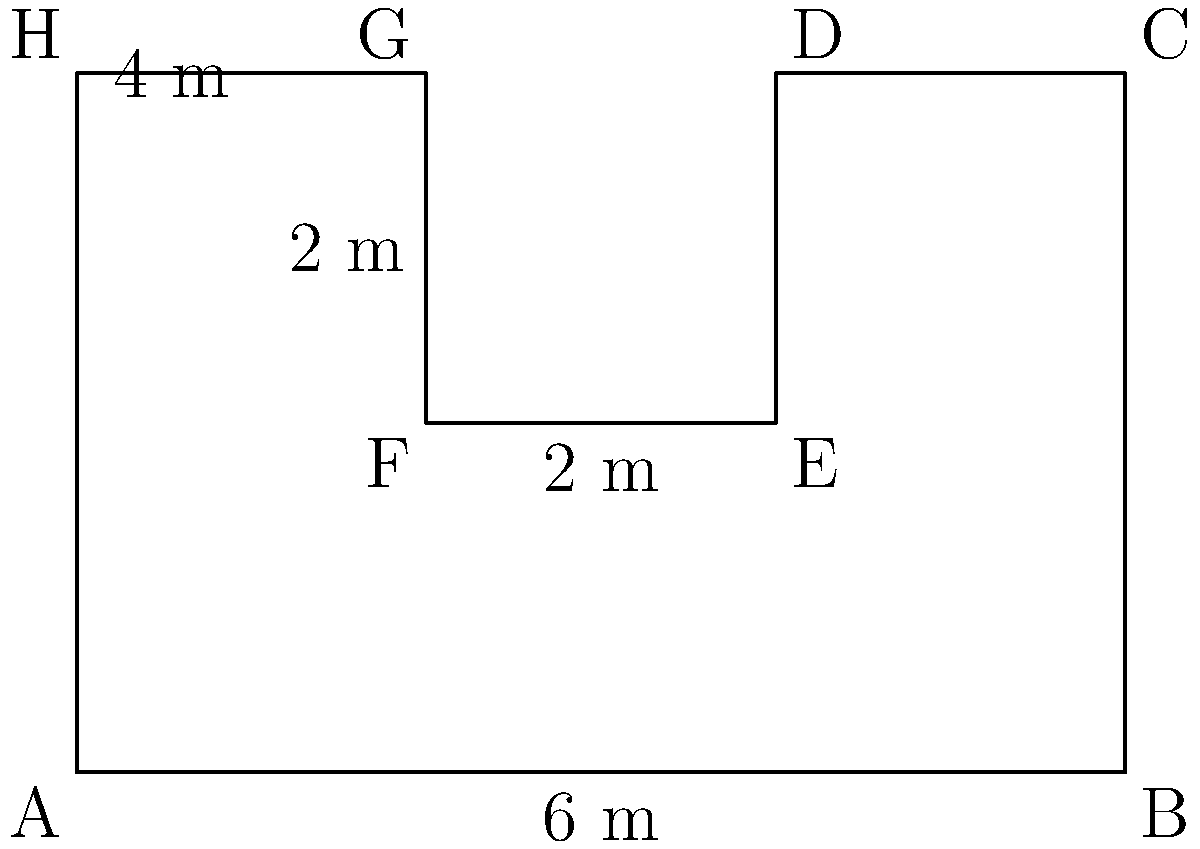In an international real estate transaction, you're tasked with calculating the total area of a complex-shaped land parcel. The parcel is represented by the figure above, where all angles are right angles. Given that the dimensions are in meters, what is the total area of this land parcel in square meters? To calculate the total area of this complex-shaped land parcel, we can break it down into rectangles and add their areas:

1. The parcel can be divided into three rectangles:
   - Rectangle 1: ABCH (the entire width and height)
   - Rectangle 2: DEFG (the small rectangle to be subtracted)
   - Rectangle 3: EFCD (the right-side rectangle to be added back)

2. Calculate the area of Rectangle 1 (ABCH):
   $$A_1 = 6m \times 4m = 24m^2$$

3. Calculate the area of Rectangle 2 (DEFG):
   $$A_2 = 2m \times 2m = 4m^2$$

4. Calculate the area of Rectangle 3 (EFCD):
   $$A_3 = 2m \times 2m = 4m^2$$

5. The total area is:
   $$A_{total} = A_1 - A_2 + A_3$$
   $$A_{total} = 24m^2 - 4m^2 + 4m^2 = 24m^2$$

Therefore, the total area of the land parcel is 24 square meters.
Answer: $24m^2$ 